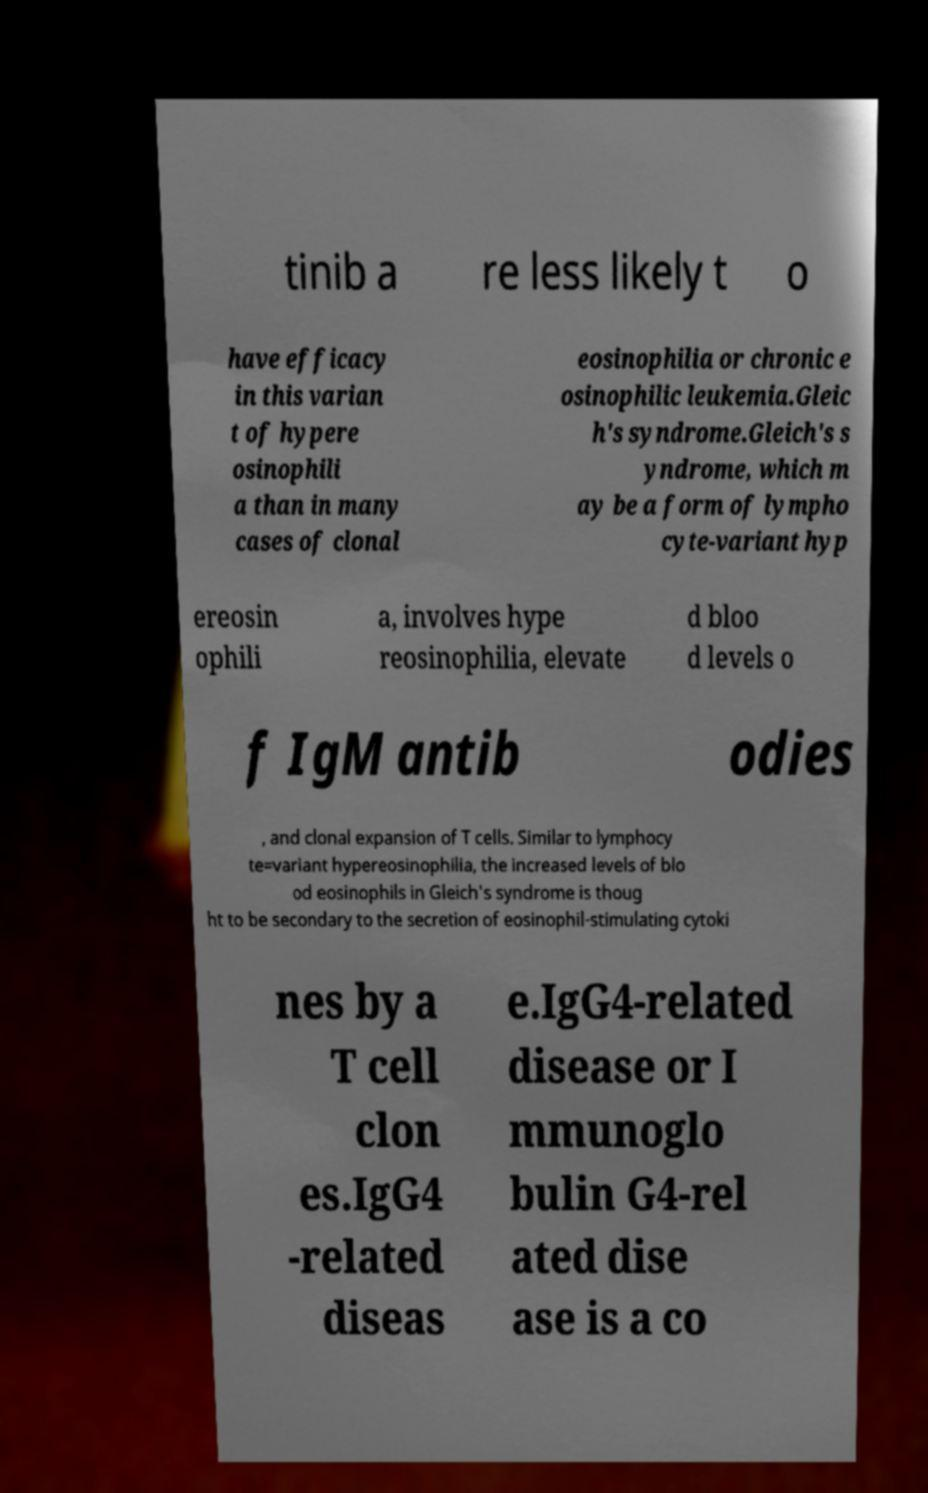What messages or text are displayed in this image? I need them in a readable, typed format. tinib a re less likely t o have efficacy in this varian t of hypere osinophili a than in many cases of clonal eosinophilia or chronic e osinophilic leukemia.Gleic h's syndrome.Gleich's s yndrome, which m ay be a form of lympho cyte-variant hyp ereosin ophili a, involves hype reosinophilia, elevate d bloo d levels o f IgM antib odies , and clonal expansion of T cells. Similar to lymphocy te=variant hypereosinophilia, the increased levels of blo od eosinophils in Gleich's syndrome is thoug ht to be secondary to the secretion of eosinophil-stimulating cytoki nes by a T cell clon es.IgG4 -related diseas e.IgG4-related disease or I mmunoglo bulin G4-rel ated dise ase is a co 